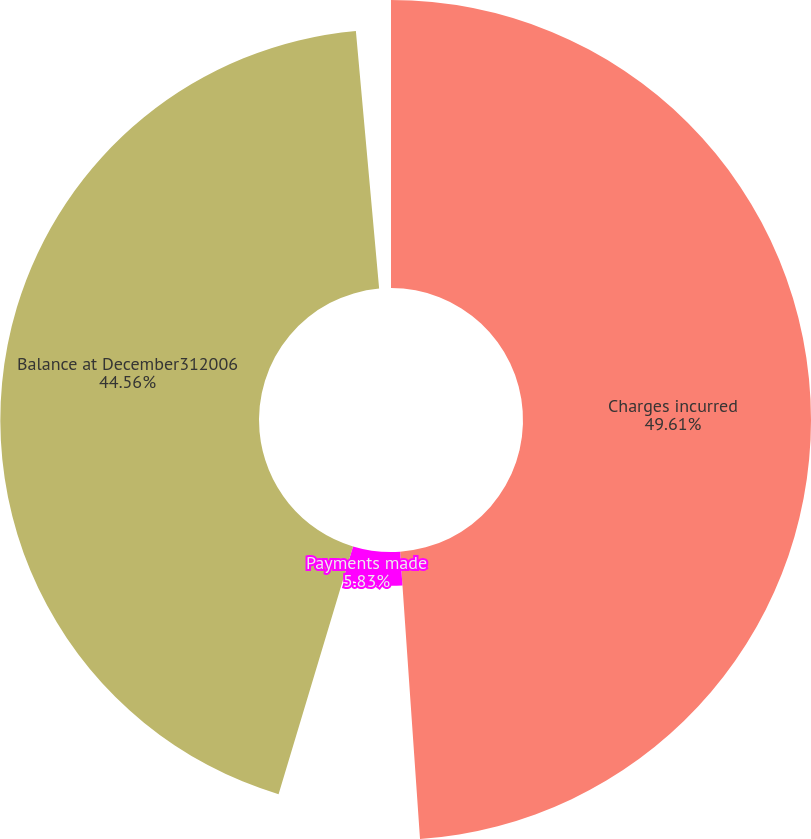Convert chart. <chart><loc_0><loc_0><loc_500><loc_500><pie_chart><fcel>Charges incurred<fcel>Payments made<fcel>Balance at December312006<nl><fcel>49.61%<fcel>5.83%<fcel>44.56%<nl></chart> 